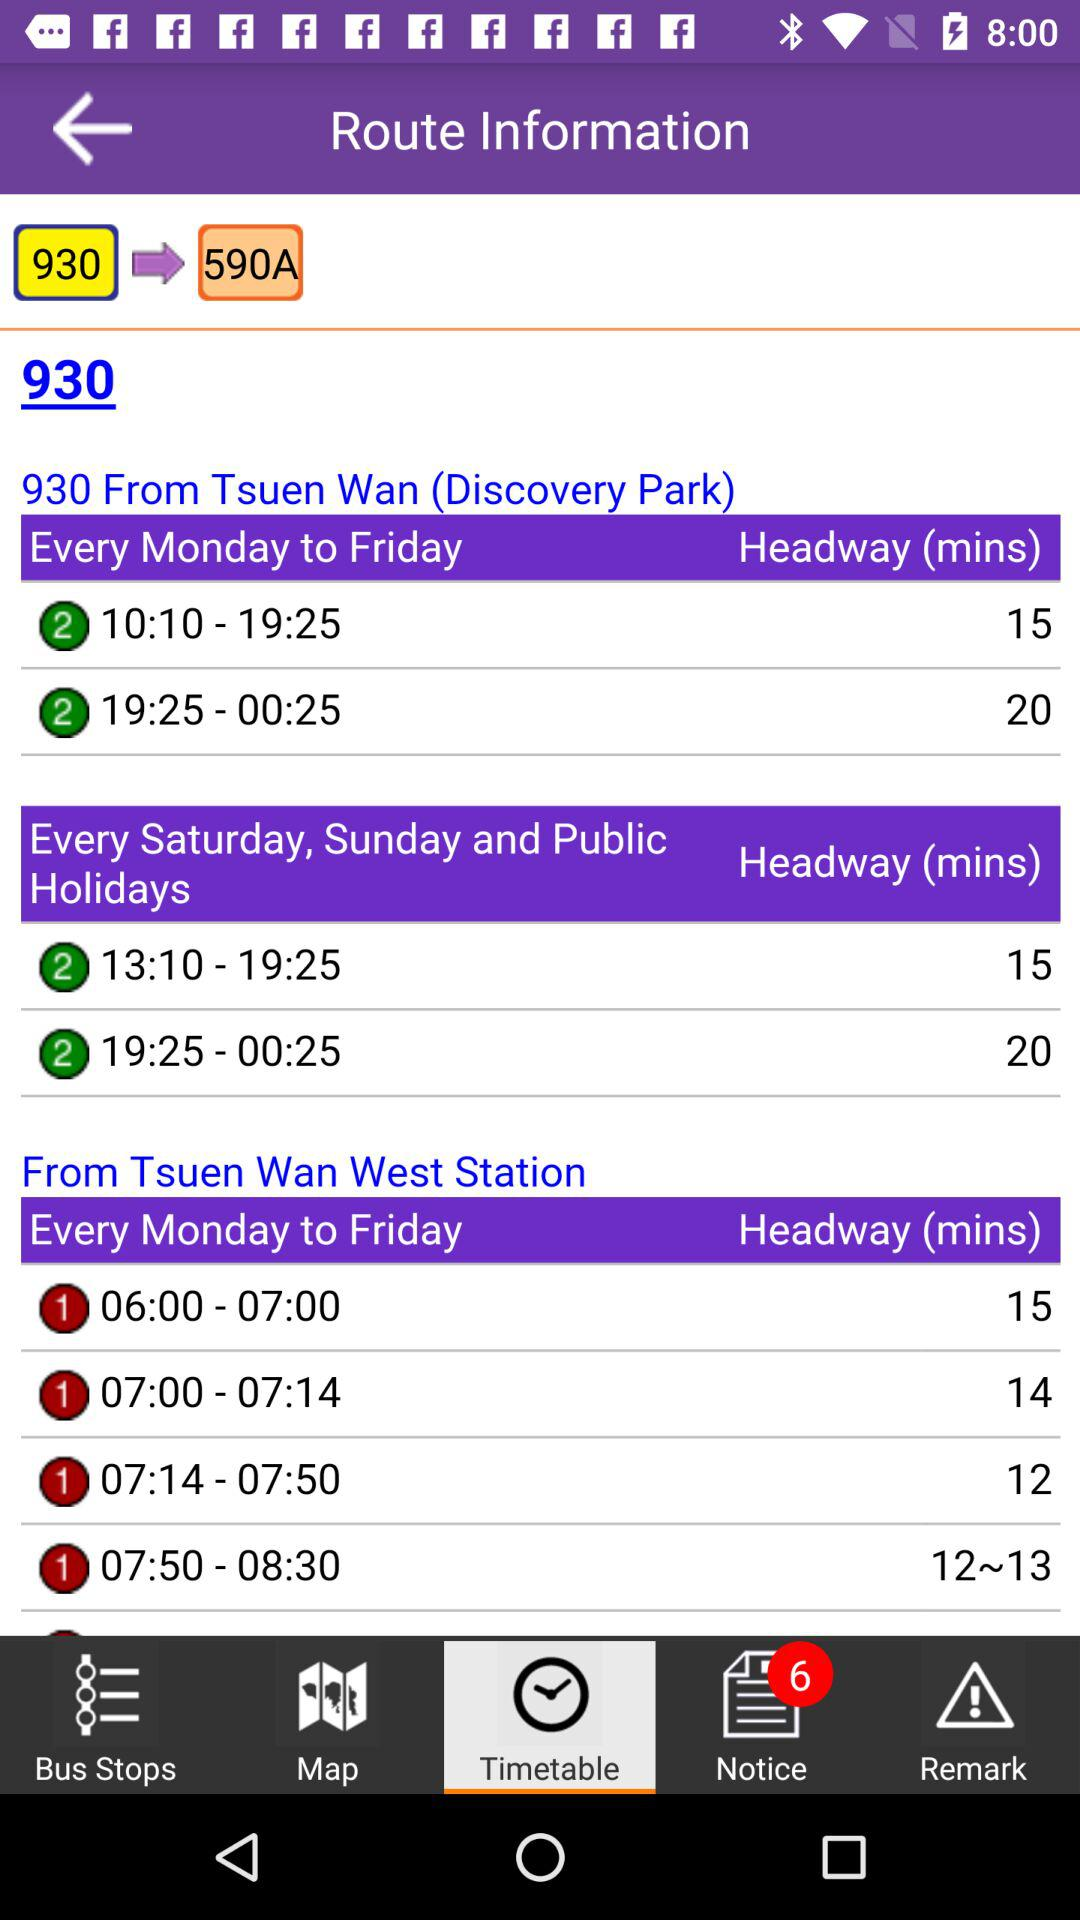Which route information is given on the screen? The information is given for route number 930 on the screen. 